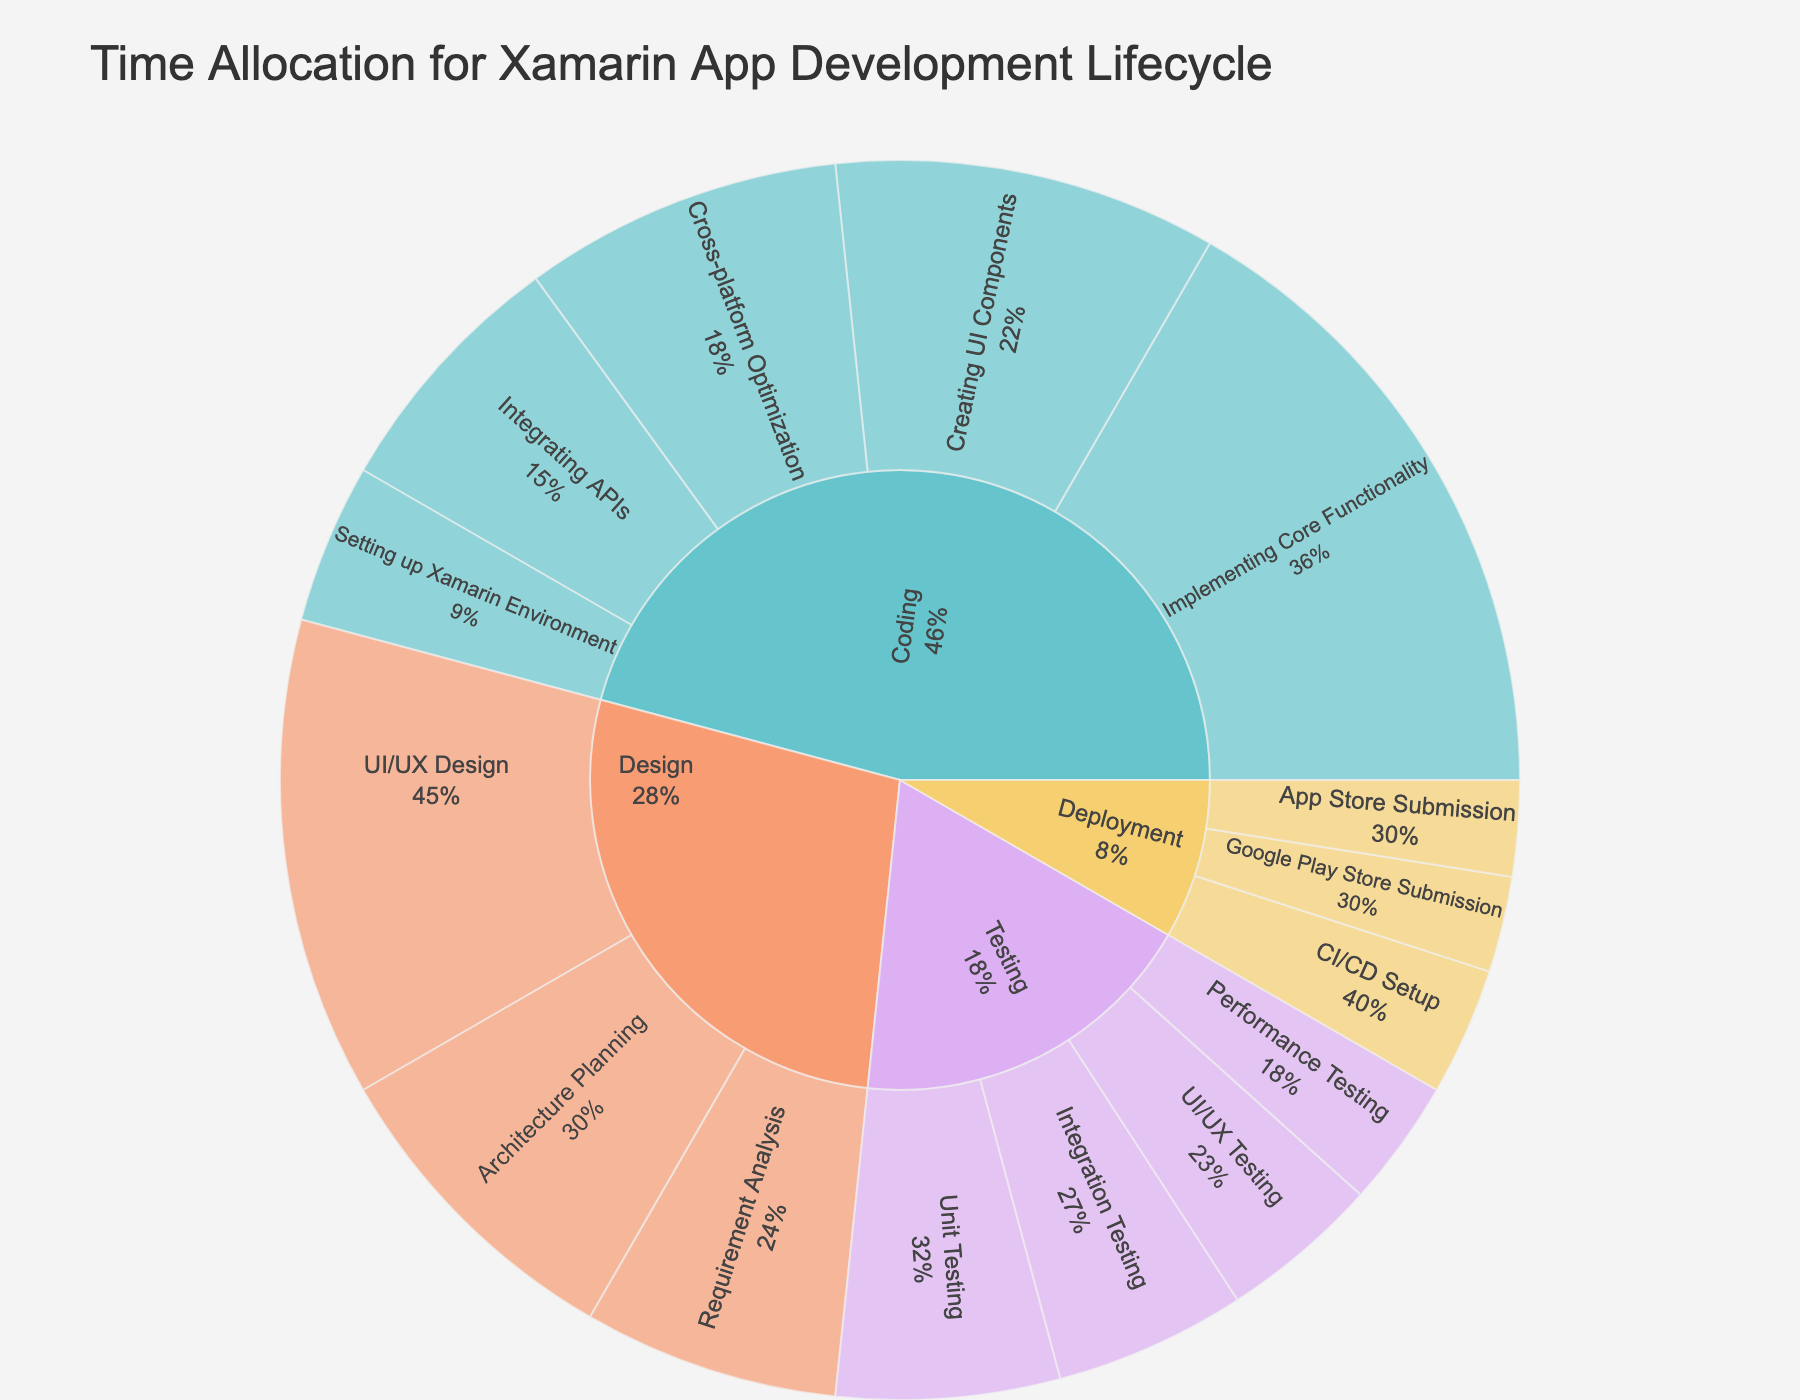what is the total time allocated for the Design stage? Sum the time allocation for all substages under the Design stage: UI/UX Design (15) + Architecture Planning (10) + Requirement Analysis (8) = 15 + 10 + 8 = 33 hours
Answer: 33 hours Which stage has the highest time allocation? Identify each stage's total time allocation and then determine which one is the highest: Design (33), Coding (55), Testing (22), Deployment (10). Coding has the highest allocation with 55 hours
Answer: Coding What percentage of the total time allocation is spent on Coding? Calculate the total time allocation: 33 (Design) + 55 (Coding) + 22 (Testing) + 10 (Deployment) = 120. Calculate the percentage for Coding: (55 / 120) * 100 = 45.83%
Answer: 45.83% Which substage within the Testing stage has the least time allocation? Compare the time allocation of each substage under Testing: Unit Testing (7), Integration Testing (6), UI/UX Testing (5), Performance Testing (4). Performance Testing has the least time allocation
Answer: Performance Testing How much time is allocated to the Integration Testing substage? Refer to the time allocation directly from the data for Integration Testing: 6 hours
Answer: 6 hours What is the cumulative time allocation for all Deployment substages? Sum the time allocation for all Deployment substages: App Store Submission (3) + Google Play Store Submission (3) + CI/CD Setup (4) = 3 + 3 + 4 = 10 hours
Answer: 10 hours How does the time spent on Creating UI Components in Coding compare to UI/UX Testing in Testing? Compare the time allocation directly: Creating UI Components (12) vs. UI/UX Testing (5). Creating UI Components has more time allocated
Answer: Creating UI Components has more time What is the percentage of time allocated to Architecture Planning within the Design stage? Calculate the percentage for Architecture Planning within its stage: (10 / 33) * 100 = 30.3%
Answer: 30.3% What is the smallest percentage of time allocated to any substage within Coding? Identify the smallest substage time, and calculate its percentage: Setting up Xamarin Environment (5) out of Coding (55): (5 / 55) * 100 = 9.09%
Answer: 9.09% Which stage has the least representation in terms of time allocation? Compare the total time allocation for each stage and identify the lowest: Design (33), Coding (55), Testing (22), Deployment (10). Deployment has the least representation
Answer: Deployment 